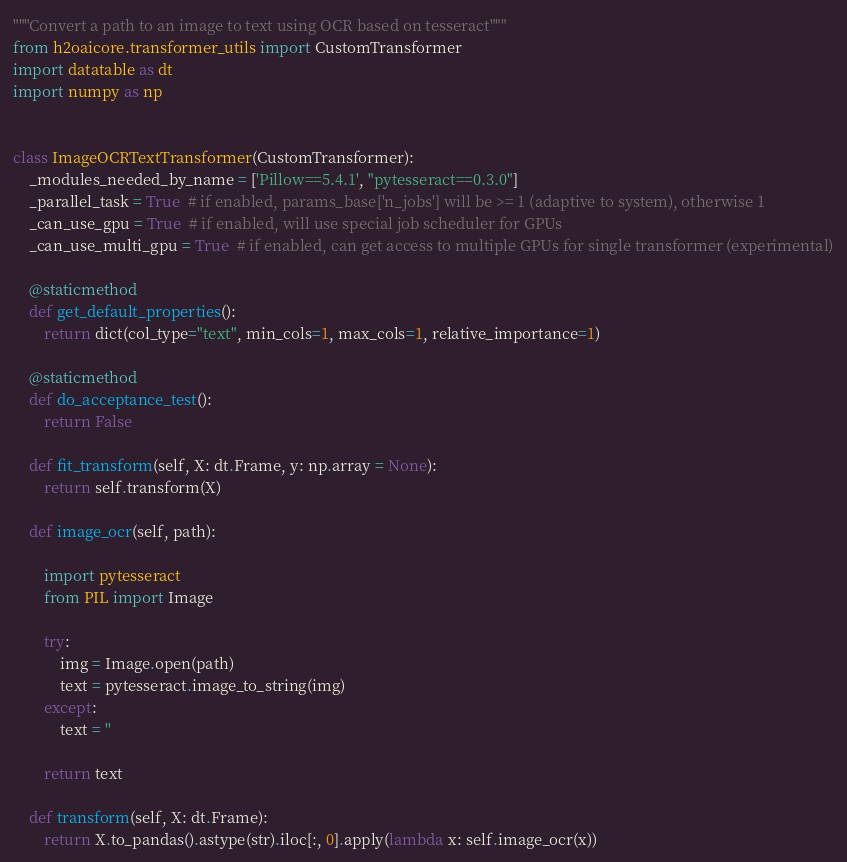<code> <loc_0><loc_0><loc_500><loc_500><_Python_>"""Convert a path to an image to text using OCR based on tesseract"""
from h2oaicore.transformer_utils import CustomTransformer
import datatable as dt
import numpy as np


class ImageOCRTextTransformer(CustomTransformer):
    _modules_needed_by_name = ['Pillow==5.4.1', "pytesseract==0.3.0"]
    _parallel_task = True  # if enabled, params_base['n_jobs'] will be >= 1 (adaptive to system), otherwise 1
    _can_use_gpu = True  # if enabled, will use special job scheduler for GPUs
    _can_use_multi_gpu = True  # if enabled, can get access to multiple GPUs for single transformer (experimental)

    @staticmethod
    def get_default_properties():
        return dict(col_type="text", min_cols=1, max_cols=1, relative_importance=1)

    @staticmethod
    def do_acceptance_test():
        return False

    def fit_transform(self, X: dt.Frame, y: np.array = None):
        return self.transform(X)

    def image_ocr(self, path):

        import pytesseract
        from PIL import Image

        try:
            img = Image.open(path)
            text = pytesseract.image_to_string(img)
        except:
            text = ''

        return text

    def transform(self, X: dt.Frame):
        return X.to_pandas().astype(str).iloc[:, 0].apply(lambda x: self.image_ocr(x))
</code> 